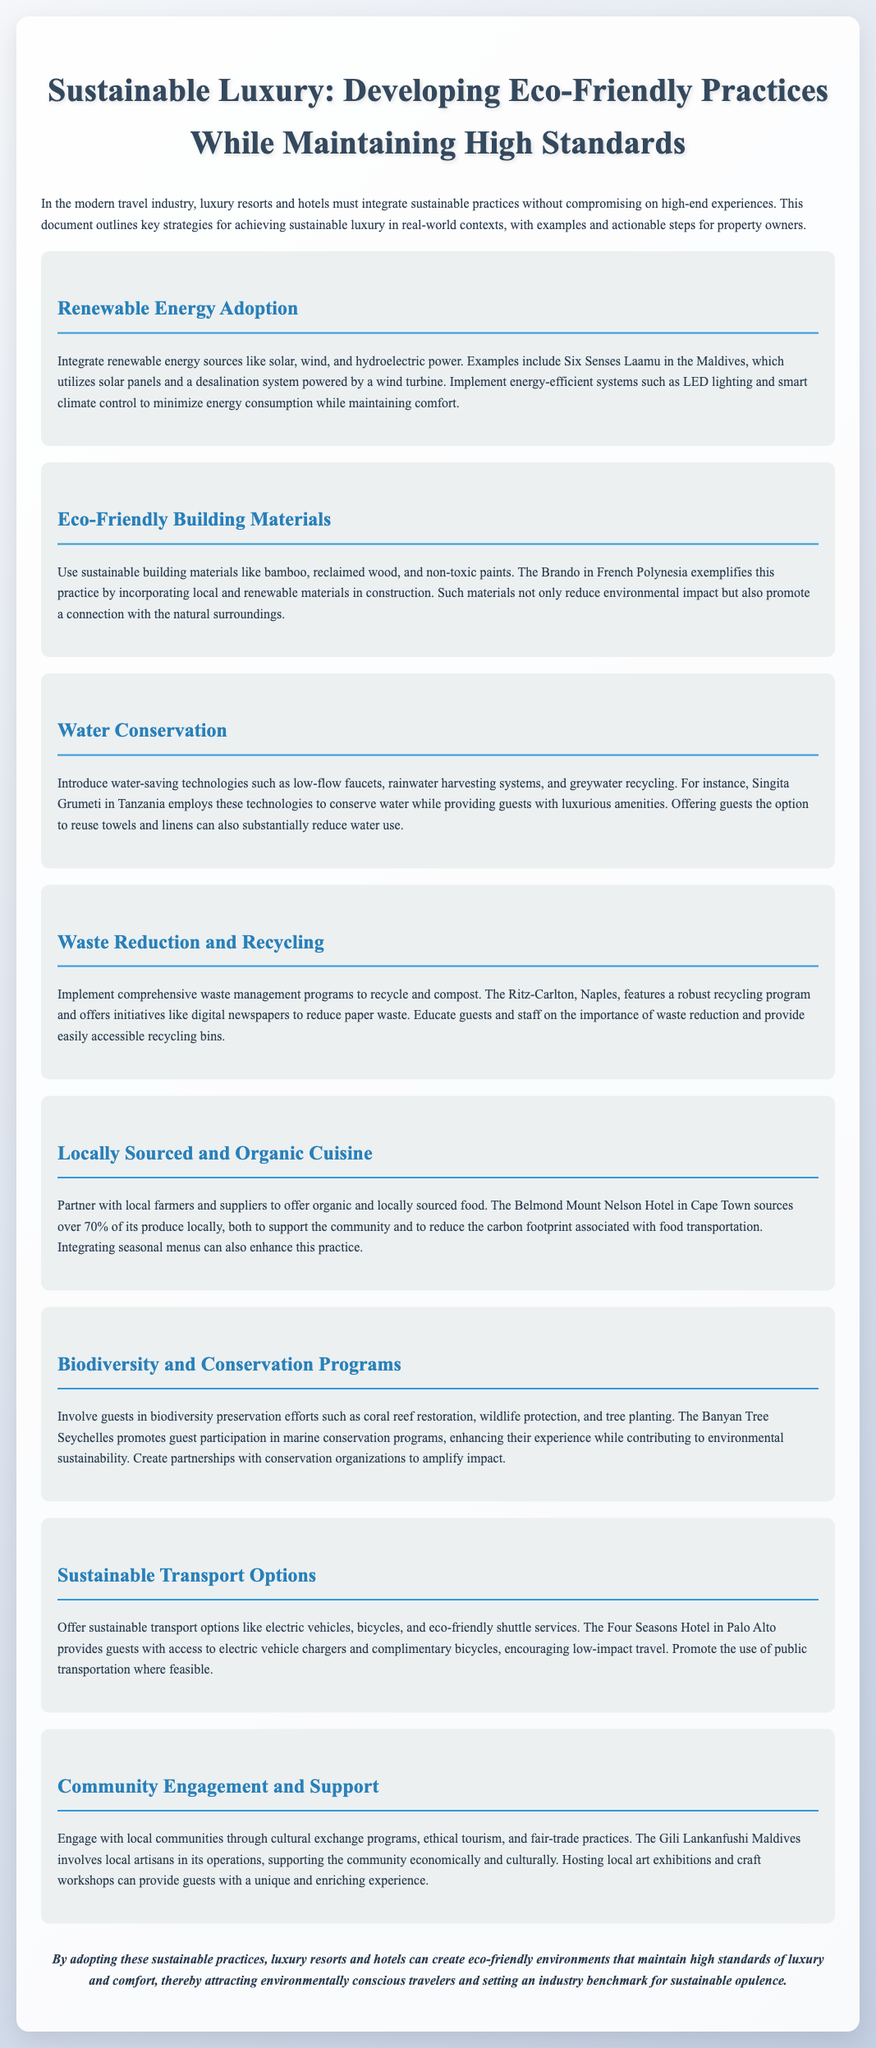What is the title of the document? The title of the document is stated prominently at the beginning of the document.
Answer: Sustainable Luxury: Developing Eco-Friendly Practices While Maintaining High Standards Which hotel uses solar panels and a wind turbine? The document provides an example of a hotel that integrates solar panels and a wind turbine for energy.
Answer: Six Senses Laamu What type of materials does The Brando use? The section discussing eco-friendly building materials mentions the types of materials used by The Brando.
Answer: Local and renewable materials What percentage of produce does Belmond Mount Nelson Hotel source locally? The document specifies the local sourcing percentage for the Belmond Mount Nelson Hotel.
Answer: Over 70% Which hotel offers electric vehicle chargers? The document mentions a hotel that provides electric vehicle chargers for guests.
Answer: Four Seasons Hotel in Palo Alto What technology does Singita Grumeti employ for water conservation? The document discusses a specific technology used by Singita Grumeti related to water conservation.
Answer: Low-flow faucets Which resort involves guests in marine conservation programs? The text describes a resort that engages guests in marine conservation efforts.
Answer: Banyan Tree Seychelles What does the Ritz-Carlton, Naples, implement for waste management? The document outlines a specific program related to waste management at the Ritz-Carlton, Naples.
Answer: Recycling program 